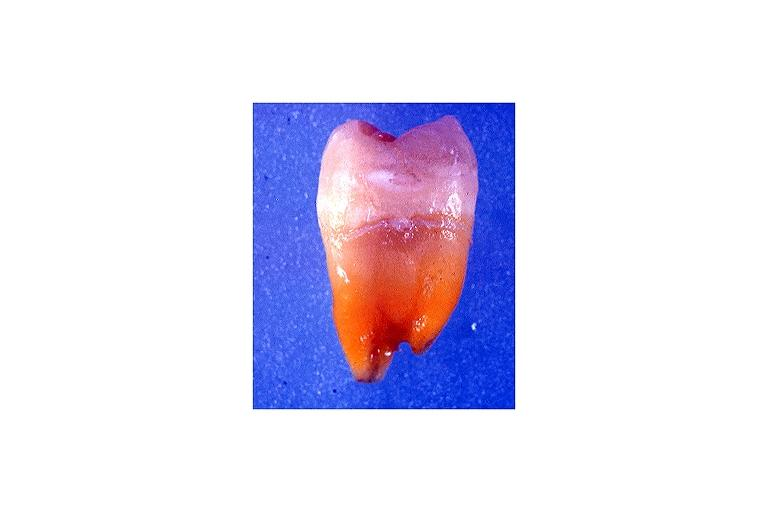what is present?
Answer the question using a single word or phrase. Oral 